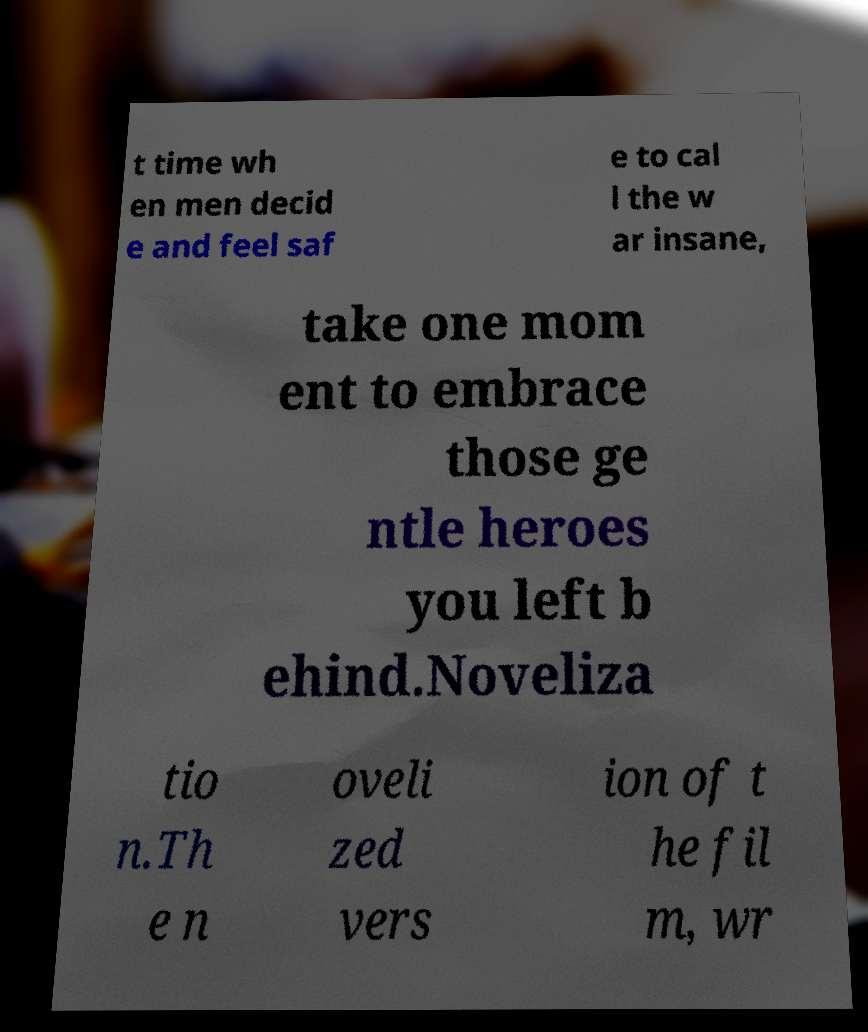Please read and relay the text visible in this image. What does it say? t time wh en men decid e and feel saf e to cal l the w ar insane, take one mom ent to embrace those ge ntle heroes you left b ehind.Noveliza tio n.Th e n oveli zed vers ion of t he fil m, wr 